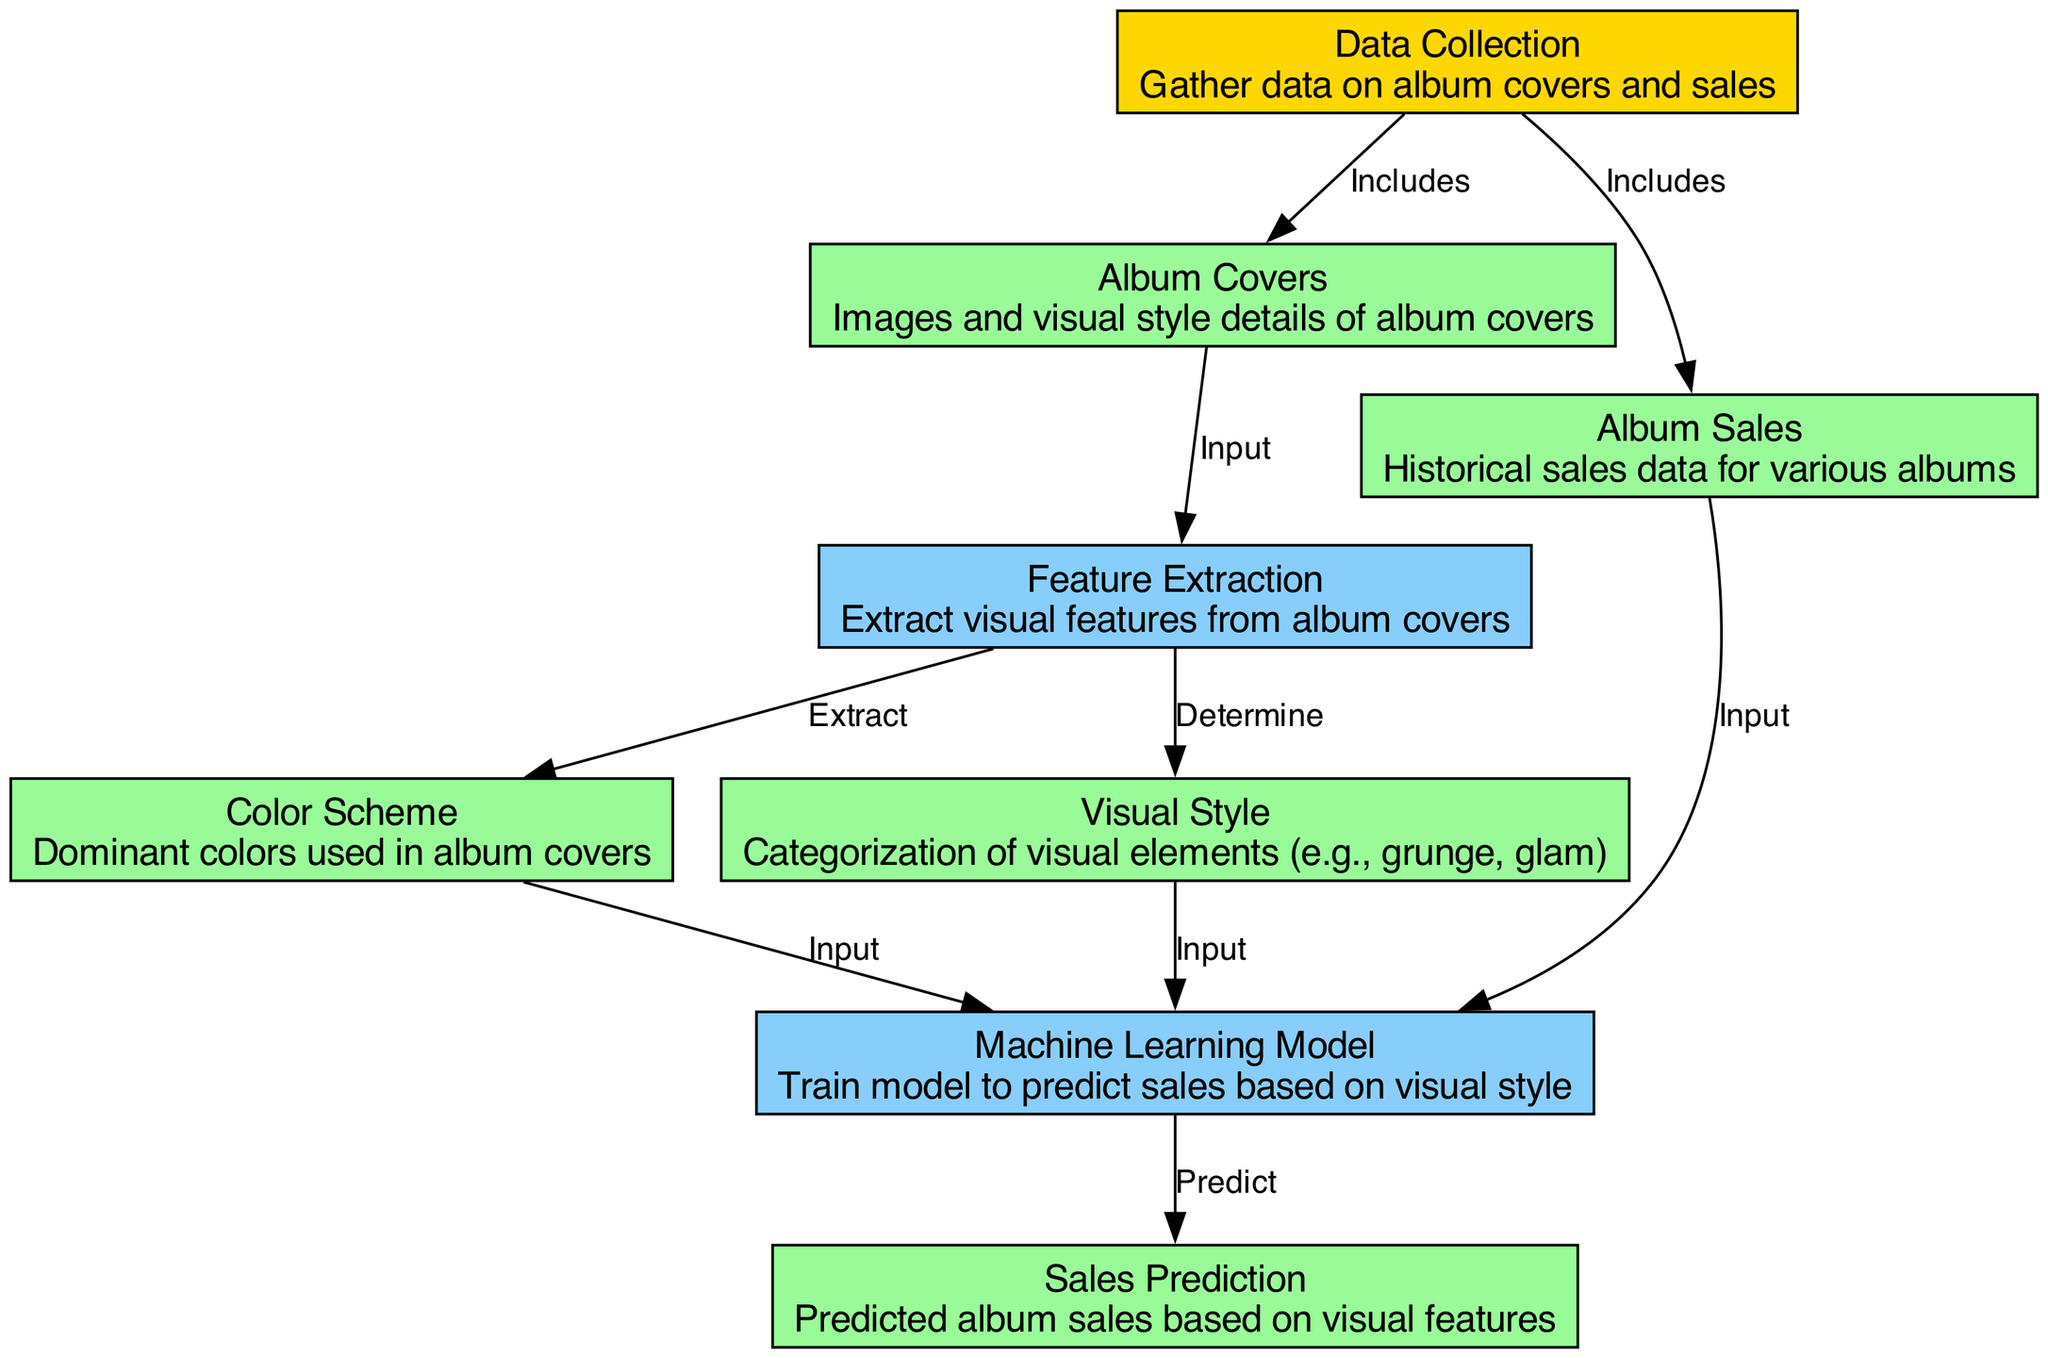What are the two primary data types included in the diagram? The diagram includes nodes for "Album Covers" and "Album Sales" under the "Data Collection" node. These identify the types of data gathered for analysis.
Answer: Album Covers, Album Sales Which node provides input to the sales prediction model? The "Machine Learning Model" node receives inputs from the "Color Scheme," "Visual Style," and "Album Sales" nodes, which contribute to predicting sales.
Answer: Color Scheme, Visual Style, Album Sales How many edges are there connecting the nodes in the diagram? By counting the connections displayed between the various nodes, it can be observed that there are a total of eight edges in the diagram.
Answer: Eight What is the main purpose of the "Feature Extraction" node? The "Feature Extraction" node determines visual features that are critical for the Machine Learning Model, focusing on both color scheme and visual style.
Answer: Extract visual features Which node categorizes visual elements such as grunge and glam? The "Visual Style" node is responsible for determining and categorizing the visual elements seen on album covers into specific styles.
Answer: Visual Style What process does the "Machine Learning Model" perform? The model takes inputs from album sales and visual data to perform predictions regarding expected sales, utilizing the features extracted.
Answer: Predict sales What is the relationship between "Album Covers" and "Feature Extraction"? The diagram indicates that "Album Covers" serves as the input to the "Feature Extraction" process, which analyzes the cover images for further details.
Answer: Input How are the origins of data for the model established in the diagram? The diagram shows that "Data Collection" is the starting point that includes both "Album Covers" and "Album Sales," indicating where the data is sourced from.
Answer: Data Collection 